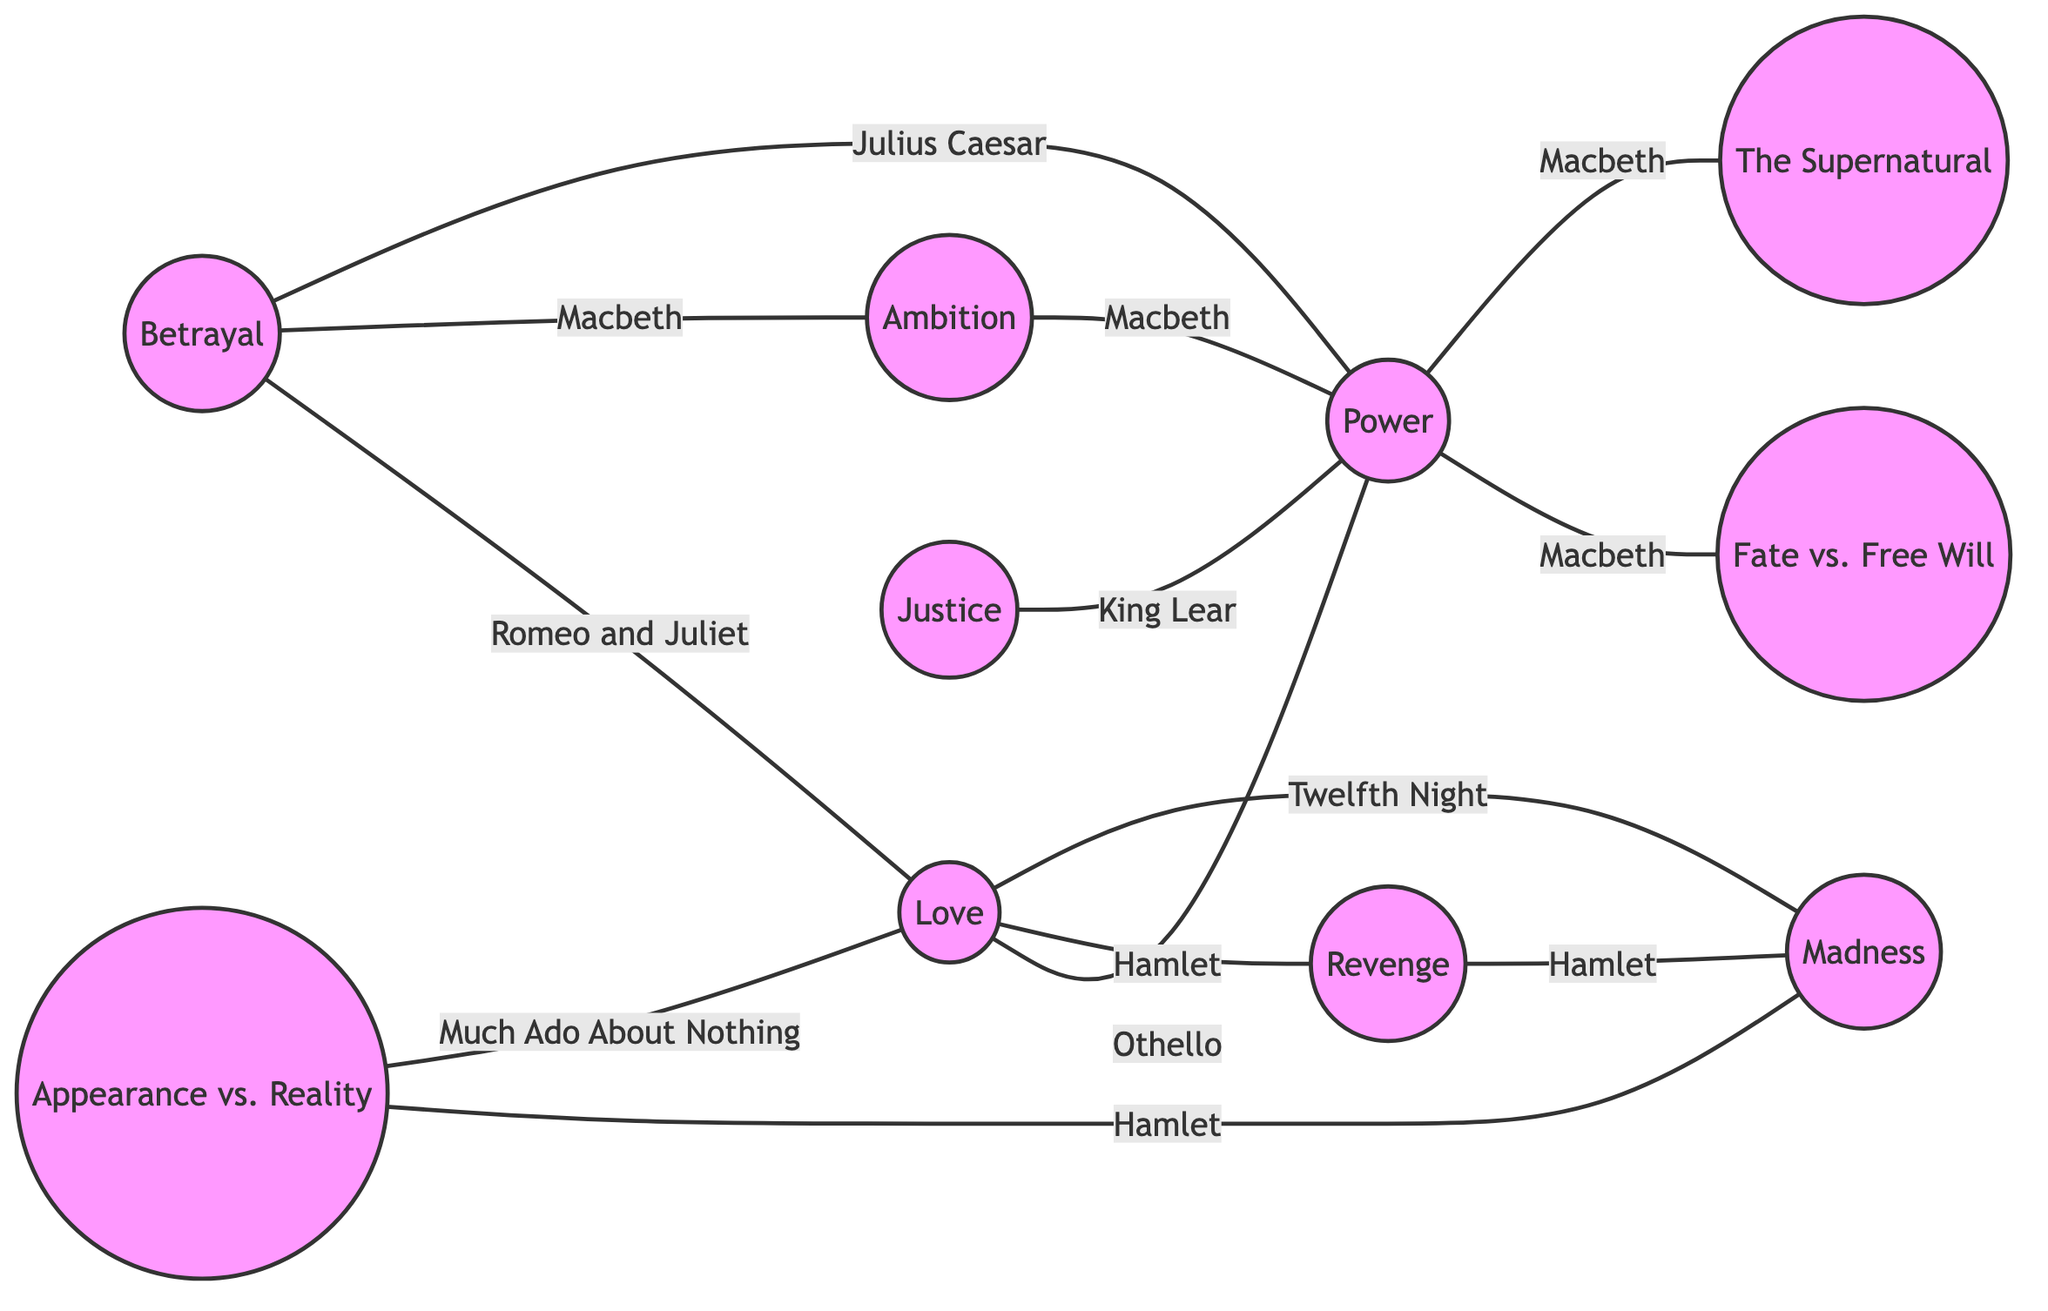What is the total number of nodes in the diagram? The diagram contains nodes for ten different themes and motifs across Shakespeare's plays. By counting the nodes listed, we find that there are ten distinct nodes labeled with different themes.
Answer: 10 Which play is associated with the theme of Betrayal and Love? Looking at the edges connected to the nodes labeled "Betrayal" and "Love," we identify that "Romeo and Juliet" is the connecting edge between these two themes in the diagram.
Answer: Romeo and Juliet How many edges are connected to the theme of Power? By examining the node labeled "Power," we can see it connects to several other themes: "Betrayal," "Love," "Ambition," "Fate vs. Free Will," "Revenge," and "The Supernatural." Counting these connections, we determine there are five edges connected to the theme of Power.
Answer: 5 Which two themes does Hamlet connect through Revenge? Analyzing the edge that connects "Revenge" leads to another node, we find it connects to "Madness," as indicated by the relationship marked from "Revenge" to "Madness" in the diagram.
Answer: Madness Identify two themes that connect through the theme of Ambition. Observing the theme of "Ambition," we note that it connects to "Betrayal" and "Power" via the respective edges. Thus, both "Betrayal" and "Power" are themes that link through "Ambition."
Answer: Betrayal, Power What is the connection between Fate vs. Free Will and the theme of Power? Looking at the node "Power," it connects to "Fate vs. Free Will" through an edge labeled with "Macbeth," indicating the thematic exploration in this play regarding the interplay between these two concepts.
Answer: Macbeth Which theme is connected to both Love and Madness? We can identify that the theme of "Love" has a connection with "Madness" through two different plays: "Hamlet" connects to "Madness" and "Twelfth Night" connects to "Love." This indicates both themes share connections with "Madness."
Answer: Madness How many unique plays are represented in the diagram? To ascertain the number of unique plays, we list all the plays mentioned in association with the edges: "Romeo and Juliet," "Macbeth," "Julius Caesar," "Othello," "Hamlet," "King Lear," and "Twelfth Night." After carefully counting, we find there are a total of seven unique plays represented.
Answer: 7 Which theme appears most frequently as a connecting point in the diagram? Investigating the connections, “Power” appears as a central node connected to multiple themes, signifying its frequent role across different relationships in the diagram. This indicates Power is the most common theme.
Answer: Power 